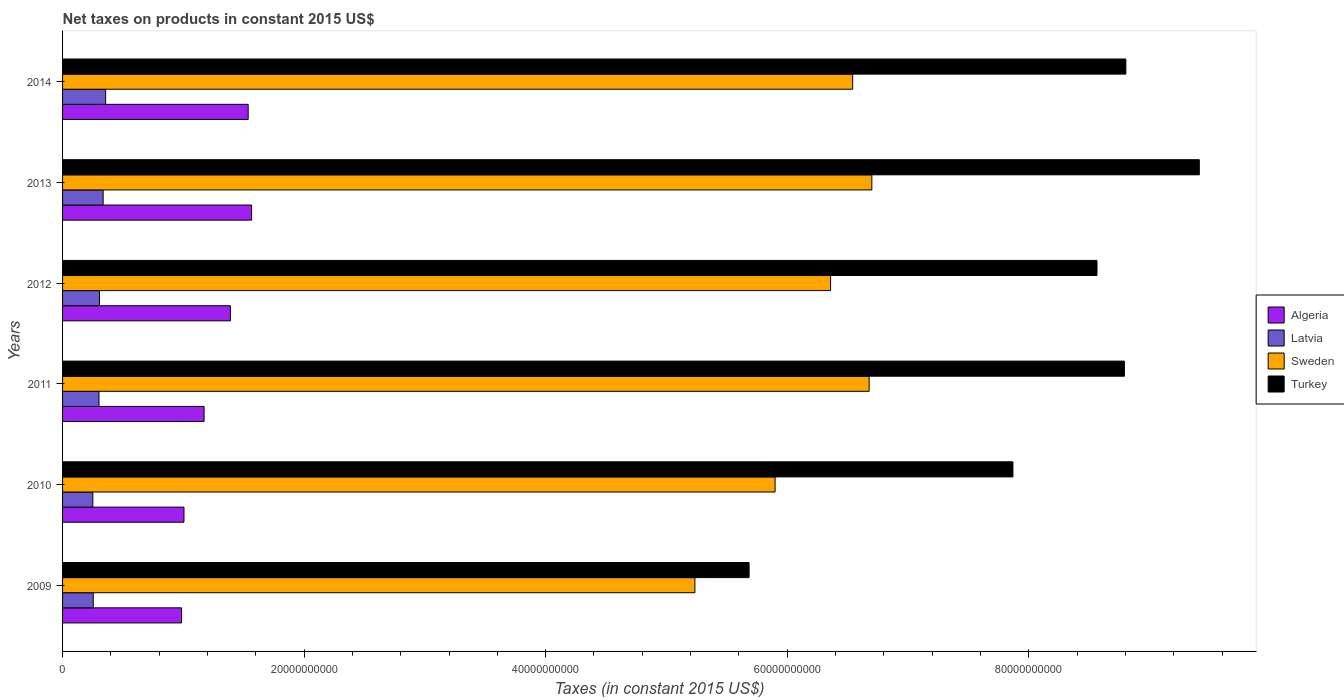How many different coloured bars are there?
Provide a short and direct response. 4. Are the number of bars on each tick of the Y-axis equal?
Your answer should be compact. Yes. What is the label of the 5th group of bars from the top?
Your answer should be compact. 2010. What is the net taxes on products in Turkey in 2010?
Your answer should be compact. 7.87e+1. Across all years, what is the maximum net taxes on products in Turkey?
Give a very brief answer. 9.41e+1. Across all years, what is the minimum net taxes on products in Sweden?
Your answer should be compact. 5.24e+1. In which year was the net taxes on products in Turkey maximum?
Offer a very short reply. 2013. In which year was the net taxes on products in Algeria minimum?
Make the answer very short. 2009. What is the total net taxes on products in Sweden in the graph?
Your answer should be compact. 3.74e+11. What is the difference between the net taxes on products in Turkey in 2009 and that in 2011?
Provide a succinct answer. -3.11e+1. What is the difference between the net taxes on products in Turkey in 2009 and the net taxes on products in Sweden in 2011?
Give a very brief answer. -9.94e+09. What is the average net taxes on products in Latvia per year?
Keep it short and to the point. 3.01e+09. In the year 2011, what is the difference between the net taxes on products in Sweden and net taxes on products in Latvia?
Provide a short and direct response. 6.38e+1. What is the ratio of the net taxes on products in Sweden in 2010 to that in 2014?
Provide a succinct answer. 0.9. Is the difference between the net taxes on products in Sweden in 2009 and 2010 greater than the difference between the net taxes on products in Latvia in 2009 and 2010?
Your response must be concise. No. What is the difference between the highest and the second highest net taxes on products in Sweden?
Provide a succinct answer. 2.24e+08. What is the difference between the highest and the lowest net taxes on products in Sweden?
Offer a terse response. 1.46e+1. In how many years, is the net taxes on products in Turkey greater than the average net taxes on products in Turkey taken over all years?
Give a very brief answer. 4. Is it the case that in every year, the sum of the net taxes on products in Algeria and net taxes on products in Turkey is greater than the sum of net taxes on products in Latvia and net taxes on products in Sweden?
Keep it short and to the point. Yes. What does the 3rd bar from the top in 2010 represents?
Provide a short and direct response. Latvia. What does the 1st bar from the bottom in 2009 represents?
Ensure brevity in your answer.  Algeria. Is it the case that in every year, the sum of the net taxes on products in Latvia and net taxes on products in Turkey is greater than the net taxes on products in Algeria?
Make the answer very short. Yes. How many bars are there?
Provide a short and direct response. 24. Are the values on the major ticks of X-axis written in scientific E-notation?
Provide a short and direct response. No. Does the graph contain any zero values?
Offer a very short reply. No. Does the graph contain grids?
Your answer should be very brief. No. Where does the legend appear in the graph?
Provide a short and direct response. Center right. How many legend labels are there?
Provide a short and direct response. 4. How are the legend labels stacked?
Provide a succinct answer. Vertical. What is the title of the graph?
Provide a short and direct response. Net taxes on products in constant 2015 US$. Does "Peru" appear as one of the legend labels in the graph?
Your response must be concise. No. What is the label or title of the X-axis?
Offer a very short reply. Taxes (in constant 2015 US$). What is the label or title of the Y-axis?
Your answer should be compact. Years. What is the Taxes (in constant 2015 US$) of Algeria in 2009?
Keep it short and to the point. 9.85e+09. What is the Taxes (in constant 2015 US$) in Latvia in 2009?
Your answer should be very brief. 2.54e+09. What is the Taxes (in constant 2015 US$) of Sweden in 2009?
Keep it short and to the point. 5.24e+1. What is the Taxes (in constant 2015 US$) in Turkey in 2009?
Your answer should be very brief. 5.68e+1. What is the Taxes (in constant 2015 US$) in Algeria in 2010?
Your response must be concise. 1.01e+1. What is the Taxes (in constant 2015 US$) of Latvia in 2010?
Offer a very short reply. 2.51e+09. What is the Taxes (in constant 2015 US$) in Sweden in 2010?
Your answer should be very brief. 5.90e+1. What is the Taxes (in constant 2015 US$) in Turkey in 2010?
Provide a succinct answer. 7.87e+1. What is the Taxes (in constant 2015 US$) of Algeria in 2011?
Offer a very short reply. 1.17e+1. What is the Taxes (in constant 2015 US$) in Latvia in 2011?
Offer a very short reply. 3.02e+09. What is the Taxes (in constant 2015 US$) of Sweden in 2011?
Provide a short and direct response. 6.68e+1. What is the Taxes (in constant 2015 US$) in Turkey in 2011?
Your response must be concise. 8.79e+1. What is the Taxes (in constant 2015 US$) in Algeria in 2012?
Give a very brief answer. 1.39e+1. What is the Taxes (in constant 2015 US$) of Latvia in 2012?
Offer a terse response. 3.06e+09. What is the Taxes (in constant 2015 US$) of Sweden in 2012?
Keep it short and to the point. 6.36e+1. What is the Taxes (in constant 2015 US$) in Turkey in 2012?
Offer a very short reply. 8.56e+1. What is the Taxes (in constant 2015 US$) of Algeria in 2013?
Ensure brevity in your answer.  1.57e+1. What is the Taxes (in constant 2015 US$) in Latvia in 2013?
Your answer should be very brief. 3.36e+09. What is the Taxes (in constant 2015 US$) of Sweden in 2013?
Provide a short and direct response. 6.70e+1. What is the Taxes (in constant 2015 US$) in Turkey in 2013?
Provide a succinct answer. 9.41e+1. What is the Taxes (in constant 2015 US$) of Algeria in 2014?
Keep it short and to the point. 1.54e+1. What is the Taxes (in constant 2015 US$) of Latvia in 2014?
Provide a short and direct response. 3.57e+09. What is the Taxes (in constant 2015 US$) of Sweden in 2014?
Keep it short and to the point. 6.54e+1. What is the Taxes (in constant 2015 US$) in Turkey in 2014?
Keep it short and to the point. 8.80e+1. Across all years, what is the maximum Taxes (in constant 2015 US$) of Algeria?
Provide a short and direct response. 1.57e+1. Across all years, what is the maximum Taxes (in constant 2015 US$) of Latvia?
Provide a short and direct response. 3.57e+09. Across all years, what is the maximum Taxes (in constant 2015 US$) in Sweden?
Give a very brief answer. 6.70e+1. Across all years, what is the maximum Taxes (in constant 2015 US$) of Turkey?
Provide a succinct answer. 9.41e+1. Across all years, what is the minimum Taxes (in constant 2015 US$) of Algeria?
Keep it short and to the point. 9.85e+09. Across all years, what is the minimum Taxes (in constant 2015 US$) in Latvia?
Your answer should be compact. 2.51e+09. Across all years, what is the minimum Taxes (in constant 2015 US$) of Sweden?
Keep it short and to the point. 5.24e+1. Across all years, what is the minimum Taxes (in constant 2015 US$) of Turkey?
Your response must be concise. 5.68e+1. What is the total Taxes (in constant 2015 US$) of Algeria in the graph?
Offer a very short reply. 7.65e+1. What is the total Taxes (in constant 2015 US$) in Latvia in the graph?
Offer a very short reply. 1.81e+1. What is the total Taxes (in constant 2015 US$) in Sweden in the graph?
Your answer should be very brief. 3.74e+11. What is the total Taxes (in constant 2015 US$) in Turkey in the graph?
Give a very brief answer. 4.91e+11. What is the difference between the Taxes (in constant 2015 US$) in Algeria in 2009 and that in 2010?
Your answer should be compact. -1.98e+08. What is the difference between the Taxes (in constant 2015 US$) in Latvia in 2009 and that in 2010?
Offer a terse response. 3.49e+07. What is the difference between the Taxes (in constant 2015 US$) of Sweden in 2009 and that in 2010?
Provide a short and direct response. -6.64e+09. What is the difference between the Taxes (in constant 2015 US$) of Turkey in 2009 and that in 2010?
Your answer should be very brief. -2.18e+1. What is the difference between the Taxes (in constant 2015 US$) of Algeria in 2009 and that in 2011?
Your answer should be very brief. -1.86e+09. What is the difference between the Taxes (in constant 2015 US$) of Latvia in 2009 and that in 2011?
Make the answer very short. -4.74e+08. What is the difference between the Taxes (in constant 2015 US$) in Sweden in 2009 and that in 2011?
Provide a short and direct response. -1.44e+1. What is the difference between the Taxes (in constant 2015 US$) in Turkey in 2009 and that in 2011?
Your answer should be compact. -3.11e+1. What is the difference between the Taxes (in constant 2015 US$) of Algeria in 2009 and that in 2012?
Offer a very short reply. -4.04e+09. What is the difference between the Taxes (in constant 2015 US$) of Latvia in 2009 and that in 2012?
Give a very brief answer. -5.15e+08. What is the difference between the Taxes (in constant 2015 US$) of Sweden in 2009 and that in 2012?
Ensure brevity in your answer.  -1.12e+1. What is the difference between the Taxes (in constant 2015 US$) of Turkey in 2009 and that in 2012?
Your response must be concise. -2.88e+1. What is the difference between the Taxes (in constant 2015 US$) of Algeria in 2009 and that in 2013?
Provide a succinct answer. -5.80e+09. What is the difference between the Taxes (in constant 2015 US$) of Latvia in 2009 and that in 2013?
Your response must be concise. -8.18e+08. What is the difference between the Taxes (in constant 2015 US$) of Sweden in 2009 and that in 2013?
Provide a succinct answer. -1.46e+1. What is the difference between the Taxes (in constant 2015 US$) in Turkey in 2009 and that in 2013?
Your answer should be very brief. -3.73e+1. What is the difference between the Taxes (in constant 2015 US$) in Algeria in 2009 and that in 2014?
Ensure brevity in your answer.  -5.52e+09. What is the difference between the Taxes (in constant 2015 US$) of Latvia in 2009 and that in 2014?
Provide a short and direct response. -1.02e+09. What is the difference between the Taxes (in constant 2015 US$) of Sweden in 2009 and that in 2014?
Offer a very short reply. -1.31e+1. What is the difference between the Taxes (in constant 2015 US$) of Turkey in 2009 and that in 2014?
Keep it short and to the point. -3.12e+1. What is the difference between the Taxes (in constant 2015 US$) of Algeria in 2010 and that in 2011?
Provide a short and direct response. -1.67e+09. What is the difference between the Taxes (in constant 2015 US$) in Latvia in 2010 and that in 2011?
Your answer should be compact. -5.09e+08. What is the difference between the Taxes (in constant 2015 US$) of Sweden in 2010 and that in 2011?
Offer a terse response. -7.79e+09. What is the difference between the Taxes (in constant 2015 US$) in Turkey in 2010 and that in 2011?
Your response must be concise. -9.23e+09. What is the difference between the Taxes (in constant 2015 US$) in Algeria in 2010 and that in 2012?
Your answer should be very brief. -3.85e+09. What is the difference between the Taxes (in constant 2015 US$) in Latvia in 2010 and that in 2012?
Provide a succinct answer. -5.50e+08. What is the difference between the Taxes (in constant 2015 US$) of Sweden in 2010 and that in 2012?
Give a very brief answer. -4.60e+09. What is the difference between the Taxes (in constant 2015 US$) in Turkey in 2010 and that in 2012?
Your response must be concise. -6.96e+09. What is the difference between the Taxes (in constant 2015 US$) in Algeria in 2010 and that in 2013?
Make the answer very short. -5.60e+09. What is the difference between the Taxes (in constant 2015 US$) in Latvia in 2010 and that in 2013?
Ensure brevity in your answer.  -8.53e+08. What is the difference between the Taxes (in constant 2015 US$) in Sweden in 2010 and that in 2013?
Ensure brevity in your answer.  -8.01e+09. What is the difference between the Taxes (in constant 2015 US$) of Turkey in 2010 and that in 2013?
Keep it short and to the point. -1.54e+1. What is the difference between the Taxes (in constant 2015 US$) of Algeria in 2010 and that in 2014?
Offer a very short reply. -5.32e+09. What is the difference between the Taxes (in constant 2015 US$) in Latvia in 2010 and that in 2014?
Give a very brief answer. -1.06e+09. What is the difference between the Taxes (in constant 2015 US$) of Sweden in 2010 and that in 2014?
Your response must be concise. -6.42e+09. What is the difference between the Taxes (in constant 2015 US$) of Turkey in 2010 and that in 2014?
Your answer should be very brief. -9.35e+09. What is the difference between the Taxes (in constant 2015 US$) of Algeria in 2011 and that in 2012?
Your answer should be very brief. -2.18e+09. What is the difference between the Taxes (in constant 2015 US$) in Latvia in 2011 and that in 2012?
Your answer should be very brief. -4.15e+07. What is the difference between the Taxes (in constant 2015 US$) of Sweden in 2011 and that in 2012?
Your answer should be compact. 3.19e+09. What is the difference between the Taxes (in constant 2015 US$) in Turkey in 2011 and that in 2012?
Provide a short and direct response. 2.27e+09. What is the difference between the Taxes (in constant 2015 US$) in Algeria in 2011 and that in 2013?
Ensure brevity in your answer.  -3.93e+09. What is the difference between the Taxes (in constant 2015 US$) of Latvia in 2011 and that in 2013?
Provide a short and direct response. -3.44e+08. What is the difference between the Taxes (in constant 2015 US$) in Sweden in 2011 and that in 2013?
Make the answer very short. -2.24e+08. What is the difference between the Taxes (in constant 2015 US$) of Turkey in 2011 and that in 2013?
Provide a short and direct response. -6.20e+09. What is the difference between the Taxes (in constant 2015 US$) in Algeria in 2011 and that in 2014?
Ensure brevity in your answer.  -3.65e+09. What is the difference between the Taxes (in constant 2015 US$) of Latvia in 2011 and that in 2014?
Offer a very short reply. -5.51e+08. What is the difference between the Taxes (in constant 2015 US$) of Sweden in 2011 and that in 2014?
Your answer should be compact. 1.36e+09. What is the difference between the Taxes (in constant 2015 US$) of Turkey in 2011 and that in 2014?
Keep it short and to the point. -1.21e+08. What is the difference between the Taxes (in constant 2015 US$) in Algeria in 2012 and that in 2013?
Offer a very short reply. -1.75e+09. What is the difference between the Taxes (in constant 2015 US$) in Latvia in 2012 and that in 2013?
Offer a very short reply. -3.02e+08. What is the difference between the Taxes (in constant 2015 US$) of Sweden in 2012 and that in 2013?
Ensure brevity in your answer.  -3.42e+09. What is the difference between the Taxes (in constant 2015 US$) in Turkey in 2012 and that in 2013?
Give a very brief answer. -8.47e+09. What is the difference between the Taxes (in constant 2015 US$) in Algeria in 2012 and that in 2014?
Give a very brief answer. -1.47e+09. What is the difference between the Taxes (in constant 2015 US$) in Latvia in 2012 and that in 2014?
Offer a terse response. -5.10e+08. What is the difference between the Taxes (in constant 2015 US$) in Sweden in 2012 and that in 2014?
Give a very brief answer. -1.83e+09. What is the difference between the Taxes (in constant 2015 US$) of Turkey in 2012 and that in 2014?
Provide a succinct answer. -2.39e+09. What is the difference between the Taxes (in constant 2015 US$) of Algeria in 2013 and that in 2014?
Keep it short and to the point. 2.82e+08. What is the difference between the Taxes (in constant 2015 US$) of Latvia in 2013 and that in 2014?
Offer a very short reply. -2.07e+08. What is the difference between the Taxes (in constant 2015 US$) in Sweden in 2013 and that in 2014?
Offer a very short reply. 1.59e+09. What is the difference between the Taxes (in constant 2015 US$) of Turkey in 2013 and that in 2014?
Ensure brevity in your answer.  6.08e+09. What is the difference between the Taxes (in constant 2015 US$) of Algeria in 2009 and the Taxes (in constant 2015 US$) of Latvia in 2010?
Provide a succinct answer. 7.35e+09. What is the difference between the Taxes (in constant 2015 US$) of Algeria in 2009 and the Taxes (in constant 2015 US$) of Sweden in 2010?
Offer a terse response. -4.91e+1. What is the difference between the Taxes (in constant 2015 US$) in Algeria in 2009 and the Taxes (in constant 2015 US$) in Turkey in 2010?
Offer a very short reply. -6.88e+1. What is the difference between the Taxes (in constant 2015 US$) of Latvia in 2009 and the Taxes (in constant 2015 US$) of Sweden in 2010?
Ensure brevity in your answer.  -5.65e+1. What is the difference between the Taxes (in constant 2015 US$) of Latvia in 2009 and the Taxes (in constant 2015 US$) of Turkey in 2010?
Provide a succinct answer. -7.61e+1. What is the difference between the Taxes (in constant 2015 US$) of Sweden in 2009 and the Taxes (in constant 2015 US$) of Turkey in 2010?
Provide a short and direct response. -2.63e+1. What is the difference between the Taxes (in constant 2015 US$) of Algeria in 2009 and the Taxes (in constant 2015 US$) of Latvia in 2011?
Offer a very short reply. 6.84e+09. What is the difference between the Taxes (in constant 2015 US$) of Algeria in 2009 and the Taxes (in constant 2015 US$) of Sweden in 2011?
Your answer should be compact. -5.69e+1. What is the difference between the Taxes (in constant 2015 US$) in Algeria in 2009 and the Taxes (in constant 2015 US$) in Turkey in 2011?
Ensure brevity in your answer.  -7.81e+1. What is the difference between the Taxes (in constant 2015 US$) in Latvia in 2009 and the Taxes (in constant 2015 US$) in Sweden in 2011?
Provide a succinct answer. -6.42e+1. What is the difference between the Taxes (in constant 2015 US$) of Latvia in 2009 and the Taxes (in constant 2015 US$) of Turkey in 2011?
Provide a short and direct response. -8.54e+1. What is the difference between the Taxes (in constant 2015 US$) of Sweden in 2009 and the Taxes (in constant 2015 US$) of Turkey in 2011?
Offer a very short reply. -3.56e+1. What is the difference between the Taxes (in constant 2015 US$) in Algeria in 2009 and the Taxes (in constant 2015 US$) in Latvia in 2012?
Keep it short and to the point. 6.80e+09. What is the difference between the Taxes (in constant 2015 US$) of Algeria in 2009 and the Taxes (in constant 2015 US$) of Sweden in 2012?
Give a very brief answer. -5.37e+1. What is the difference between the Taxes (in constant 2015 US$) of Algeria in 2009 and the Taxes (in constant 2015 US$) of Turkey in 2012?
Ensure brevity in your answer.  -7.58e+1. What is the difference between the Taxes (in constant 2015 US$) in Latvia in 2009 and the Taxes (in constant 2015 US$) in Sweden in 2012?
Give a very brief answer. -6.10e+1. What is the difference between the Taxes (in constant 2015 US$) of Latvia in 2009 and the Taxes (in constant 2015 US$) of Turkey in 2012?
Offer a very short reply. -8.31e+1. What is the difference between the Taxes (in constant 2015 US$) in Sweden in 2009 and the Taxes (in constant 2015 US$) in Turkey in 2012?
Make the answer very short. -3.33e+1. What is the difference between the Taxes (in constant 2015 US$) of Algeria in 2009 and the Taxes (in constant 2015 US$) of Latvia in 2013?
Ensure brevity in your answer.  6.49e+09. What is the difference between the Taxes (in constant 2015 US$) in Algeria in 2009 and the Taxes (in constant 2015 US$) in Sweden in 2013?
Make the answer very short. -5.72e+1. What is the difference between the Taxes (in constant 2015 US$) of Algeria in 2009 and the Taxes (in constant 2015 US$) of Turkey in 2013?
Provide a short and direct response. -8.43e+1. What is the difference between the Taxes (in constant 2015 US$) in Latvia in 2009 and the Taxes (in constant 2015 US$) in Sweden in 2013?
Ensure brevity in your answer.  -6.45e+1. What is the difference between the Taxes (in constant 2015 US$) in Latvia in 2009 and the Taxes (in constant 2015 US$) in Turkey in 2013?
Make the answer very short. -9.16e+1. What is the difference between the Taxes (in constant 2015 US$) of Sweden in 2009 and the Taxes (in constant 2015 US$) of Turkey in 2013?
Provide a succinct answer. -4.18e+1. What is the difference between the Taxes (in constant 2015 US$) of Algeria in 2009 and the Taxes (in constant 2015 US$) of Latvia in 2014?
Offer a terse response. 6.29e+09. What is the difference between the Taxes (in constant 2015 US$) of Algeria in 2009 and the Taxes (in constant 2015 US$) of Sweden in 2014?
Offer a very short reply. -5.56e+1. What is the difference between the Taxes (in constant 2015 US$) of Algeria in 2009 and the Taxes (in constant 2015 US$) of Turkey in 2014?
Provide a short and direct response. -7.82e+1. What is the difference between the Taxes (in constant 2015 US$) of Latvia in 2009 and the Taxes (in constant 2015 US$) of Sweden in 2014?
Give a very brief answer. -6.29e+1. What is the difference between the Taxes (in constant 2015 US$) in Latvia in 2009 and the Taxes (in constant 2015 US$) in Turkey in 2014?
Make the answer very short. -8.55e+1. What is the difference between the Taxes (in constant 2015 US$) of Sweden in 2009 and the Taxes (in constant 2015 US$) of Turkey in 2014?
Your response must be concise. -3.57e+1. What is the difference between the Taxes (in constant 2015 US$) of Algeria in 2010 and the Taxes (in constant 2015 US$) of Latvia in 2011?
Your response must be concise. 7.04e+09. What is the difference between the Taxes (in constant 2015 US$) in Algeria in 2010 and the Taxes (in constant 2015 US$) in Sweden in 2011?
Provide a short and direct response. -5.67e+1. What is the difference between the Taxes (in constant 2015 US$) in Algeria in 2010 and the Taxes (in constant 2015 US$) in Turkey in 2011?
Offer a terse response. -7.79e+1. What is the difference between the Taxes (in constant 2015 US$) in Latvia in 2010 and the Taxes (in constant 2015 US$) in Sweden in 2011?
Ensure brevity in your answer.  -6.43e+1. What is the difference between the Taxes (in constant 2015 US$) in Latvia in 2010 and the Taxes (in constant 2015 US$) in Turkey in 2011?
Your answer should be compact. -8.54e+1. What is the difference between the Taxes (in constant 2015 US$) in Sweden in 2010 and the Taxes (in constant 2015 US$) in Turkey in 2011?
Make the answer very short. -2.89e+1. What is the difference between the Taxes (in constant 2015 US$) of Algeria in 2010 and the Taxes (in constant 2015 US$) of Latvia in 2012?
Offer a terse response. 6.99e+09. What is the difference between the Taxes (in constant 2015 US$) of Algeria in 2010 and the Taxes (in constant 2015 US$) of Sweden in 2012?
Keep it short and to the point. -5.35e+1. What is the difference between the Taxes (in constant 2015 US$) of Algeria in 2010 and the Taxes (in constant 2015 US$) of Turkey in 2012?
Provide a short and direct response. -7.56e+1. What is the difference between the Taxes (in constant 2015 US$) in Latvia in 2010 and the Taxes (in constant 2015 US$) in Sweden in 2012?
Keep it short and to the point. -6.11e+1. What is the difference between the Taxes (in constant 2015 US$) of Latvia in 2010 and the Taxes (in constant 2015 US$) of Turkey in 2012?
Your response must be concise. -8.31e+1. What is the difference between the Taxes (in constant 2015 US$) of Sweden in 2010 and the Taxes (in constant 2015 US$) of Turkey in 2012?
Your response must be concise. -2.67e+1. What is the difference between the Taxes (in constant 2015 US$) of Algeria in 2010 and the Taxes (in constant 2015 US$) of Latvia in 2013?
Ensure brevity in your answer.  6.69e+09. What is the difference between the Taxes (in constant 2015 US$) in Algeria in 2010 and the Taxes (in constant 2015 US$) in Sweden in 2013?
Offer a very short reply. -5.70e+1. What is the difference between the Taxes (in constant 2015 US$) of Algeria in 2010 and the Taxes (in constant 2015 US$) of Turkey in 2013?
Offer a terse response. -8.41e+1. What is the difference between the Taxes (in constant 2015 US$) in Latvia in 2010 and the Taxes (in constant 2015 US$) in Sweden in 2013?
Ensure brevity in your answer.  -6.45e+1. What is the difference between the Taxes (in constant 2015 US$) in Latvia in 2010 and the Taxes (in constant 2015 US$) in Turkey in 2013?
Make the answer very short. -9.16e+1. What is the difference between the Taxes (in constant 2015 US$) of Sweden in 2010 and the Taxes (in constant 2015 US$) of Turkey in 2013?
Keep it short and to the point. -3.51e+1. What is the difference between the Taxes (in constant 2015 US$) in Algeria in 2010 and the Taxes (in constant 2015 US$) in Latvia in 2014?
Give a very brief answer. 6.48e+09. What is the difference between the Taxes (in constant 2015 US$) in Algeria in 2010 and the Taxes (in constant 2015 US$) in Sweden in 2014?
Your response must be concise. -5.54e+1. What is the difference between the Taxes (in constant 2015 US$) in Algeria in 2010 and the Taxes (in constant 2015 US$) in Turkey in 2014?
Offer a terse response. -7.80e+1. What is the difference between the Taxes (in constant 2015 US$) of Latvia in 2010 and the Taxes (in constant 2015 US$) of Sweden in 2014?
Your response must be concise. -6.29e+1. What is the difference between the Taxes (in constant 2015 US$) of Latvia in 2010 and the Taxes (in constant 2015 US$) of Turkey in 2014?
Give a very brief answer. -8.55e+1. What is the difference between the Taxes (in constant 2015 US$) of Sweden in 2010 and the Taxes (in constant 2015 US$) of Turkey in 2014?
Provide a succinct answer. -2.90e+1. What is the difference between the Taxes (in constant 2015 US$) in Algeria in 2011 and the Taxes (in constant 2015 US$) in Latvia in 2012?
Ensure brevity in your answer.  8.66e+09. What is the difference between the Taxes (in constant 2015 US$) of Algeria in 2011 and the Taxes (in constant 2015 US$) of Sweden in 2012?
Make the answer very short. -5.19e+1. What is the difference between the Taxes (in constant 2015 US$) of Algeria in 2011 and the Taxes (in constant 2015 US$) of Turkey in 2012?
Offer a terse response. -7.39e+1. What is the difference between the Taxes (in constant 2015 US$) of Latvia in 2011 and the Taxes (in constant 2015 US$) of Sweden in 2012?
Your response must be concise. -6.06e+1. What is the difference between the Taxes (in constant 2015 US$) in Latvia in 2011 and the Taxes (in constant 2015 US$) in Turkey in 2012?
Provide a short and direct response. -8.26e+1. What is the difference between the Taxes (in constant 2015 US$) of Sweden in 2011 and the Taxes (in constant 2015 US$) of Turkey in 2012?
Offer a terse response. -1.89e+1. What is the difference between the Taxes (in constant 2015 US$) of Algeria in 2011 and the Taxes (in constant 2015 US$) of Latvia in 2013?
Keep it short and to the point. 8.36e+09. What is the difference between the Taxes (in constant 2015 US$) in Algeria in 2011 and the Taxes (in constant 2015 US$) in Sweden in 2013?
Give a very brief answer. -5.53e+1. What is the difference between the Taxes (in constant 2015 US$) in Algeria in 2011 and the Taxes (in constant 2015 US$) in Turkey in 2013?
Provide a short and direct response. -8.24e+1. What is the difference between the Taxes (in constant 2015 US$) in Latvia in 2011 and the Taxes (in constant 2015 US$) in Sweden in 2013?
Make the answer very short. -6.40e+1. What is the difference between the Taxes (in constant 2015 US$) in Latvia in 2011 and the Taxes (in constant 2015 US$) in Turkey in 2013?
Offer a very short reply. -9.11e+1. What is the difference between the Taxes (in constant 2015 US$) of Sweden in 2011 and the Taxes (in constant 2015 US$) of Turkey in 2013?
Offer a very short reply. -2.73e+1. What is the difference between the Taxes (in constant 2015 US$) in Algeria in 2011 and the Taxes (in constant 2015 US$) in Latvia in 2014?
Provide a succinct answer. 8.15e+09. What is the difference between the Taxes (in constant 2015 US$) in Algeria in 2011 and the Taxes (in constant 2015 US$) in Sweden in 2014?
Your answer should be compact. -5.37e+1. What is the difference between the Taxes (in constant 2015 US$) of Algeria in 2011 and the Taxes (in constant 2015 US$) of Turkey in 2014?
Provide a short and direct response. -7.63e+1. What is the difference between the Taxes (in constant 2015 US$) in Latvia in 2011 and the Taxes (in constant 2015 US$) in Sweden in 2014?
Your answer should be compact. -6.24e+1. What is the difference between the Taxes (in constant 2015 US$) of Latvia in 2011 and the Taxes (in constant 2015 US$) of Turkey in 2014?
Keep it short and to the point. -8.50e+1. What is the difference between the Taxes (in constant 2015 US$) in Sweden in 2011 and the Taxes (in constant 2015 US$) in Turkey in 2014?
Offer a very short reply. -2.13e+1. What is the difference between the Taxes (in constant 2015 US$) of Algeria in 2012 and the Taxes (in constant 2015 US$) of Latvia in 2013?
Make the answer very short. 1.05e+1. What is the difference between the Taxes (in constant 2015 US$) in Algeria in 2012 and the Taxes (in constant 2015 US$) in Sweden in 2013?
Offer a terse response. -5.31e+1. What is the difference between the Taxes (in constant 2015 US$) of Algeria in 2012 and the Taxes (in constant 2015 US$) of Turkey in 2013?
Ensure brevity in your answer.  -8.02e+1. What is the difference between the Taxes (in constant 2015 US$) of Latvia in 2012 and the Taxes (in constant 2015 US$) of Sweden in 2013?
Your response must be concise. -6.39e+1. What is the difference between the Taxes (in constant 2015 US$) in Latvia in 2012 and the Taxes (in constant 2015 US$) in Turkey in 2013?
Your answer should be compact. -9.11e+1. What is the difference between the Taxes (in constant 2015 US$) in Sweden in 2012 and the Taxes (in constant 2015 US$) in Turkey in 2013?
Your response must be concise. -3.05e+1. What is the difference between the Taxes (in constant 2015 US$) in Algeria in 2012 and the Taxes (in constant 2015 US$) in Latvia in 2014?
Offer a terse response. 1.03e+1. What is the difference between the Taxes (in constant 2015 US$) of Algeria in 2012 and the Taxes (in constant 2015 US$) of Sweden in 2014?
Keep it short and to the point. -5.15e+1. What is the difference between the Taxes (in constant 2015 US$) of Algeria in 2012 and the Taxes (in constant 2015 US$) of Turkey in 2014?
Your response must be concise. -7.41e+1. What is the difference between the Taxes (in constant 2015 US$) in Latvia in 2012 and the Taxes (in constant 2015 US$) in Sweden in 2014?
Make the answer very short. -6.24e+1. What is the difference between the Taxes (in constant 2015 US$) in Latvia in 2012 and the Taxes (in constant 2015 US$) in Turkey in 2014?
Provide a succinct answer. -8.50e+1. What is the difference between the Taxes (in constant 2015 US$) of Sweden in 2012 and the Taxes (in constant 2015 US$) of Turkey in 2014?
Ensure brevity in your answer.  -2.44e+1. What is the difference between the Taxes (in constant 2015 US$) in Algeria in 2013 and the Taxes (in constant 2015 US$) in Latvia in 2014?
Keep it short and to the point. 1.21e+1. What is the difference between the Taxes (in constant 2015 US$) in Algeria in 2013 and the Taxes (in constant 2015 US$) in Sweden in 2014?
Provide a succinct answer. -4.98e+1. What is the difference between the Taxes (in constant 2015 US$) of Algeria in 2013 and the Taxes (in constant 2015 US$) of Turkey in 2014?
Your answer should be very brief. -7.24e+1. What is the difference between the Taxes (in constant 2015 US$) of Latvia in 2013 and the Taxes (in constant 2015 US$) of Sweden in 2014?
Your answer should be very brief. -6.21e+1. What is the difference between the Taxes (in constant 2015 US$) of Latvia in 2013 and the Taxes (in constant 2015 US$) of Turkey in 2014?
Your answer should be very brief. -8.47e+1. What is the difference between the Taxes (in constant 2015 US$) of Sweden in 2013 and the Taxes (in constant 2015 US$) of Turkey in 2014?
Offer a terse response. -2.10e+1. What is the average Taxes (in constant 2015 US$) in Algeria per year?
Offer a terse response. 1.28e+1. What is the average Taxes (in constant 2015 US$) of Latvia per year?
Your answer should be compact. 3.01e+09. What is the average Taxes (in constant 2015 US$) of Sweden per year?
Keep it short and to the point. 6.24e+1. What is the average Taxes (in constant 2015 US$) in Turkey per year?
Keep it short and to the point. 8.19e+1. In the year 2009, what is the difference between the Taxes (in constant 2015 US$) of Algeria and Taxes (in constant 2015 US$) of Latvia?
Keep it short and to the point. 7.31e+09. In the year 2009, what is the difference between the Taxes (in constant 2015 US$) of Algeria and Taxes (in constant 2015 US$) of Sweden?
Your answer should be compact. -4.25e+1. In the year 2009, what is the difference between the Taxes (in constant 2015 US$) of Algeria and Taxes (in constant 2015 US$) of Turkey?
Give a very brief answer. -4.70e+1. In the year 2009, what is the difference between the Taxes (in constant 2015 US$) of Latvia and Taxes (in constant 2015 US$) of Sweden?
Offer a terse response. -4.98e+1. In the year 2009, what is the difference between the Taxes (in constant 2015 US$) in Latvia and Taxes (in constant 2015 US$) in Turkey?
Provide a succinct answer. -5.43e+1. In the year 2009, what is the difference between the Taxes (in constant 2015 US$) in Sweden and Taxes (in constant 2015 US$) in Turkey?
Provide a succinct answer. -4.49e+09. In the year 2010, what is the difference between the Taxes (in constant 2015 US$) in Algeria and Taxes (in constant 2015 US$) in Latvia?
Your response must be concise. 7.54e+09. In the year 2010, what is the difference between the Taxes (in constant 2015 US$) in Algeria and Taxes (in constant 2015 US$) in Sweden?
Ensure brevity in your answer.  -4.89e+1. In the year 2010, what is the difference between the Taxes (in constant 2015 US$) of Algeria and Taxes (in constant 2015 US$) of Turkey?
Your answer should be very brief. -6.86e+1. In the year 2010, what is the difference between the Taxes (in constant 2015 US$) of Latvia and Taxes (in constant 2015 US$) of Sweden?
Make the answer very short. -5.65e+1. In the year 2010, what is the difference between the Taxes (in constant 2015 US$) of Latvia and Taxes (in constant 2015 US$) of Turkey?
Provide a succinct answer. -7.62e+1. In the year 2010, what is the difference between the Taxes (in constant 2015 US$) in Sweden and Taxes (in constant 2015 US$) in Turkey?
Your response must be concise. -1.97e+1. In the year 2011, what is the difference between the Taxes (in constant 2015 US$) of Algeria and Taxes (in constant 2015 US$) of Latvia?
Your response must be concise. 8.70e+09. In the year 2011, what is the difference between the Taxes (in constant 2015 US$) in Algeria and Taxes (in constant 2015 US$) in Sweden?
Offer a very short reply. -5.51e+1. In the year 2011, what is the difference between the Taxes (in constant 2015 US$) in Algeria and Taxes (in constant 2015 US$) in Turkey?
Offer a very short reply. -7.62e+1. In the year 2011, what is the difference between the Taxes (in constant 2015 US$) of Latvia and Taxes (in constant 2015 US$) of Sweden?
Your response must be concise. -6.38e+1. In the year 2011, what is the difference between the Taxes (in constant 2015 US$) of Latvia and Taxes (in constant 2015 US$) of Turkey?
Ensure brevity in your answer.  -8.49e+1. In the year 2011, what is the difference between the Taxes (in constant 2015 US$) of Sweden and Taxes (in constant 2015 US$) of Turkey?
Your response must be concise. -2.11e+1. In the year 2012, what is the difference between the Taxes (in constant 2015 US$) of Algeria and Taxes (in constant 2015 US$) of Latvia?
Make the answer very short. 1.08e+1. In the year 2012, what is the difference between the Taxes (in constant 2015 US$) of Algeria and Taxes (in constant 2015 US$) of Sweden?
Provide a succinct answer. -4.97e+1. In the year 2012, what is the difference between the Taxes (in constant 2015 US$) of Algeria and Taxes (in constant 2015 US$) of Turkey?
Keep it short and to the point. -7.18e+1. In the year 2012, what is the difference between the Taxes (in constant 2015 US$) of Latvia and Taxes (in constant 2015 US$) of Sweden?
Offer a terse response. -6.05e+1. In the year 2012, what is the difference between the Taxes (in constant 2015 US$) in Latvia and Taxes (in constant 2015 US$) in Turkey?
Keep it short and to the point. -8.26e+1. In the year 2012, what is the difference between the Taxes (in constant 2015 US$) in Sweden and Taxes (in constant 2015 US$) in Turkey?
Provide a short and direct response. -2.21e+1. In the year 2013, what is the difference between the Taxes (in constant 2015 US$) of Algeria and Taxes (in constant 2015 US$) of Latvia?
Provide a succinct answer. 1.23e+1. In the year 2013, what is the difference between the Taxes (in constant 2015 US$) of Algeria and Taxes (in constant 2015 US$) of Sweden?
Provide a short and direct response. -5.14e+1. In the year 2013, what is the difference between the Taxes (in constant 2015 US$) of Algeria and Taxes (in constant 2015 US$) of Turkey?
Ensure brevity in your answer.  -7.85e+1. In the year 2013, what is the difference between the Taxes (in constant 2015 US$) of Latvia and Taxes (in constant 2015 US$) of Sweden?
Your answer should be compact. -6.36e+1. In the year 2013, what is the difference between the Taxes (in constant 2015 US$) of Latvia and Taxes (in constant 2015 US$) of Turkey?
Your answer should be very brief. -9.08e+1. In the year 2013, what is the difference between the Taxes (in constant 2015 US$) in Sweden and Taxes (in constant 2015 US$) in Turkey?
Provide a succinct answer. -2.71e+1. In the year 2014, what is the difference between the Taxes (in constant 2015 US$) of Algeria and Taxes (in constant 2015 US$) of Latvia?
Make the answer very short. 1.18e+1. In the year 2014, what is the difference between the Taxes (in constant 2015 US$) in Algeria and Taxes (in constant 2015 US$) in Sweden?
Give a very brief answer. -5.00e+1. In the year 2014, what is the difference between the Taxes (in constant 2015 US$) in Algeria and Taxes (in constant 2015 US$) in Turkey?
Provide a short and direct response. -7.27e+1. In the year 2014, what is the difference between the Taxes (in constant 2015 US$) of Latvia and Taxes (in constant 2015 US$) of Sweden?
Make the answer very short. -6.19e+1. In the year 2014, what is the difference between the Taxes (in constant 2015 US$) of Latvia and Taxes (in constant 2015 US$) of Turkey?
Your answer should be very brief. -8.45e+1. In the year 2014, what is the difference between the Taxes (in constant 2015 US$) of Sweden and Taxes (in constant 2015 US$) of Turkey?
Make the answer very short. -2.26e+1. What is the ratio of the Taxes (in constant 2015 US$) in Algeria in 2009 to that in 2010?
Give a very brief answer. 0.98. What is the ratio of the Taxes (in constant 2015 US$) in Latvia in 2009 to that in 2010?
Your answer should be compact. 1.01. What is the ratio of the Taxes (in constant 2015 US$) of Sweden in 2009 to that in 2010?
Make the answer very short. 0.89. What is the ratio of the Taxes (in constant 2015 US$) of Turkey in 2009 to that in 2010?
Your response must be concise. 0.72. What is the ratio of the Taxes (in constant 2015 US$) of Algeria in 2009 to that in 2011?
Your response must be concise. 0.84. What is the ratio of the Taxes (in constant 2015 US$) in Latvia in 2009 to that in 2011?
Offer a very short reply. 0.84. What is the ratio of the Taxes (in constant 2015 US$) in Sweden in 2009 to that in 2011?
Ensure brevity in your answer.  0.78. What is the ratio of the Taxes (in constant 2015 US$) in Turkey in 2009 to that in 2011?
Keep it short and to the point. 0.65. What is the ratio of the Taxes (in constant 2015 US$) of Algeria in 2009 to that in 2012?
Your answer should be compact. 0.71. What is the ratio of the Taxes (in constant 2015 US$) in Latvia in 2009 to that in 2012?
Ensure brevity in your answer.  0.83. What is the ratio of the Taxes (in constant 2015 US$) in Sweden in 2009 to that in 2012?
Your response must be concise. 0.82. What is the ratio of the Taxes (in constant 2015 US$) in Turkey in 2009 to that in 2012?
Ensure brevity in your answer.  0.66. What is the ratio of the Taxes (in constant 2015 US$) in Algeria in 2009 to that in 2013?
Your answer should be very brief. 0.63. What is the ratio of the Taxes (in constant 2015 US$) of Latvia in 2009 to that in 2013?
Provide a succinct answer. 0.76. What is the ratio of the Taxes (in constant 2015 US$) of Sweden in 2009 to that in 2013?
Offer a terse response. 0.78. What is the ratio of the Taxes (in constant 2015 US$) of Turkey in 2009 to that in 2013?
Make the answer very short. 0.6. What is the ratio of the Taxes (in constant 2015 US$) in Algeria in 2009 to that in 2014?
Offer a very short reply. 0.64. What is the ratio of the Taxes (in constant 2015 US$) in Latvia in 2009 to that in 2014?
Provide a short and direct response. 0.71. What is the ratio of the Taxes (in constant 2015 US$) in Sweden in 2009 to that in 2014?
Make the answer very short. 0.8. What is the ratio of the Taxes (in constant 2015 US$) of Turkey in 2009 to that in 2014?
Give a very brief answer. 0.65. What is the ratio of the Taxes (in constant 2015 US$) of Algeria in 2010 to that in 2011?
Your answer should be very brief. 0.86. What is the ratio of the Taxes (in constant 2015 US$) in Latvia in 2010 to that in 2011?
Provide a succinct answer. 0.83. What is the ratio of the Taxes (in constant 2015 US$) in Sweden in 2010 to that in 2011?
Provide a succinct answer. 0.88. What is the ratio of the Taxes (in constant 2015 US$) in Turkey in 2010 to that in 2011?
Provide a succinct answer. 0.9. What is the ratio of the Taxes (in constant 2015 US$) of Algeria in 2010 to that in 2012?
Your answer should be compact. 0.72. What is the ratio of the Taxes (in constant 2015 US$) of Latvia in 2010 to that in 2012?
Your answer should be compact. 0.82. What is the ratio of the Taxes (in constant 2015 US$) of Sweden in 2010 to that in 2012?
Your response must be concise. 0.93. What is the ratio of the Taxes (in constant 2015 US$) of Turkey in 2010 to that in 2012?
Make the answer very short. 0.92. What is the ratio of the Taxes (in constant 2015 US$) in Algeria in 2010 to that in 2013?
Give a very brief answer. 0.64. What is the ratio of the Taxes (in constant 2015 US$) of Latvia in 2010 to that in 2013?
Make the answer very short. 0.75. What is the ratio of the Taxes (in constant 2015 US$) of Sweden in 2010 to that in 2013?
Your response must be concise. 0.88. What is the ratio of the Taxes (in constant 2015 US$) of Turkey in 2010 to that in 2013?
Provide a succinct answer. 0.84. What is the ratio of the Taxes (in constant 2015 US$) of Algeria in 2010 to that in 2014?
Make the answer very short. 0.65. What is the ratio of the Taxes (in constant 2015 US$) of Latvia in 2010 to that in 2014?
Make the answer very short. 0.7. What is the ratio of the Taxes (in constant 2015 US$) of Sweden in 2010 to that in 2014?
Make the answer very short. 0.9. What is the ratio of the Taxes (in constant 2015 US$) in Turkey in 2010 to that in 2014?
Ensure brevity in your answer.  0.89. What is the ratio of the Taxes (in constant 2015 US$) in Algeria in 2011 to that in 2012?
Your answer should be compact. 0.84. What is the ratio of the Taxes (in constant 2015 US$) in Latvia in 2011 to that in 2012?
Provide a succinct answer. 0.99. What is the ratio of the Taxes (in constant 2015 US$) of Sweden in 2011 to that in 2012?
Provide a short and direct response. 1.05. What is the ratio of the Taxes (in constant 2015 US$) in Turkey in 2011 to that in 2012?
Your response must be concise. 1.03. What is the ratio of the Taxes (in constant 2015 US$) in Algeria in 2011 to that in 2013?
Ensure brevity in your answer.  0.75. What is the ratio of the Taxes (in constant 2015 US$) of Latvia in 2011 to that in 2013?
Make the answer very short. 0.9. What is the ratio of the Taxes (in constant 2015 US$) of Sweden in 2011 to that in 2013?
Your answer should be compact. 1. What is the ratio of the Taxes (in constant 2015 US$) of Turkey in 2011 to that in 2013?
Provide a short and direct response. 0.93. What is the ratio of the Taxes (in constant 2015 US$) in Algeria in 2011 to that in 2014?
Provide a succinct answer. 0.76. What is the ratio of the Taxes (in constant 2015 US$) of Latvia in 2011 to that in 2014?
Give a very brief answer. 0.85. What is the ratio of the Taxes (in constant 2015 US$) of Sweden in 2011 to that in 2014?
Keep it short and to the point. 1.02. What is the ratio of the Taxes (in constant 2015 US$) in Turkey in 2011 to that in 2014?
Offer a very short reply. 1. What is the ratio of the Taxes (in constant 2015 US$) in Algeria in 2012 to that in 2013?
Ensure brevity in your answer.  0.89. What is the ratio of the Taxes (in constant 2015 US$) in Latvia in 2012 to that in 2013?
Offer a very short reply. 0.91. What is the ratio of the Taxes (in constant 2015 US$) in Sweden in 2012 to that in 2013?
Your answer should be compact. 0.95. What is the ratio of the Taxes (in constant 2015 US$) in Turkey in 2012 to that in 2013?
Keep it short and to the point. 0.91. What is the ratio of the Taxes (in constant 2015 US$) in Algeria in 2012 to that in 2014?
Provide a short and direct response. 0.9. What is the ratio of the Taxes (in constant 2015 US$) of Sweden in 2012 to that in 2014?
Offer a terse response. 0.97. What is the ratio of the Taxes (in constant 2015 US$) of Turkey in 2012 to that in 2014?
Provide a short and direct response. 0.97. What is the ratio of the Taxes (in constant 2015 US$) in Algeria in 2013 to that in 2014?
Offer a terse response. 1.02. What is the ratio of the Taxes (in constant 2015 US$) of Latvia in 2013 to that in 2014?
Provide a succinct answer. 0.94. What is the ratio of the Taxes (in constant 2015 US$) of Sweden in 2013 to that in 2014?
Offer a terse response. 1.02. What is the ratio of the Taxes (in constant 2015 US$) in Turkey in 2013 to that in 2014?
Your answer should be very brief. 1.07. What is the difference between the highest and the second highest Taxes (in constant 2015 US$) in Algeria?
Provide a succinct answer. 2.82e+08. What is the difference between the highest and the second highest Taxes (in constant 2015 US$) in Latvia?
Provide a succinct answer. 2.07e+08. What is the difference between the highest and the second highest Taxes (in constant 2015 US$) of Sweden?
Your answer should be very brief. 2.24e+08. What is the difference between the highest and the second highest Taxes (in constant 2015 US$) of Turkey?
Your answer should be very brief. 6.08e+09. What is the difference between the highest and the lowest Taxes (in constant 2015 US$) of Algeria?
Your answer should be very brief. 5.80e+09. What is the difference between the highest and the lowest Taxes (in constant 2015 US$) in Latvia?
Your answer should be very brief. 1.06e+09. What is the difference between the highest and the lowest Taxes (in constant 2015 US$) in Sweden?
Your response must be concise. 1.46e+1. What is the difference between the highest and the lowest Taxes (in constant 2015 US$) of Turkey?
Ensure brevity in your answer.  3.73e+1. 